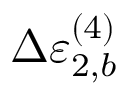Convert formula to latex. <formula><loc_0><loc_0><loc_500><loc_500>\Delta \varepsilon _ { 2 , b } ^ { ( 4 ) }</formula> 